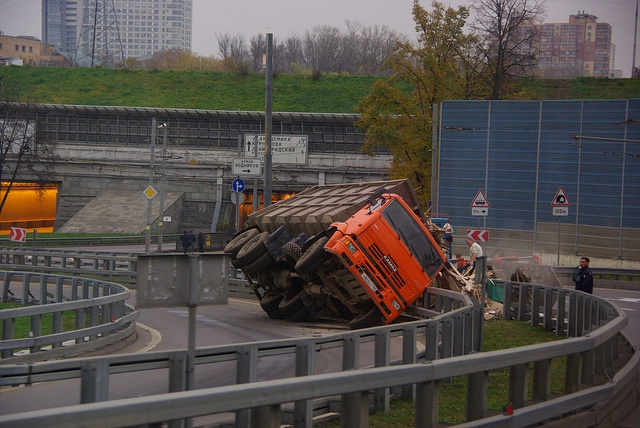Describe the objects in this image and their specific colors. I can see truck in gray, black, brown, and maroon tones, people in gray, black, brown, and darkgray tones, people in gray, black, and maroon tones, people in gray and black tones, and people in gray, black, and darkblue tones in this image. 